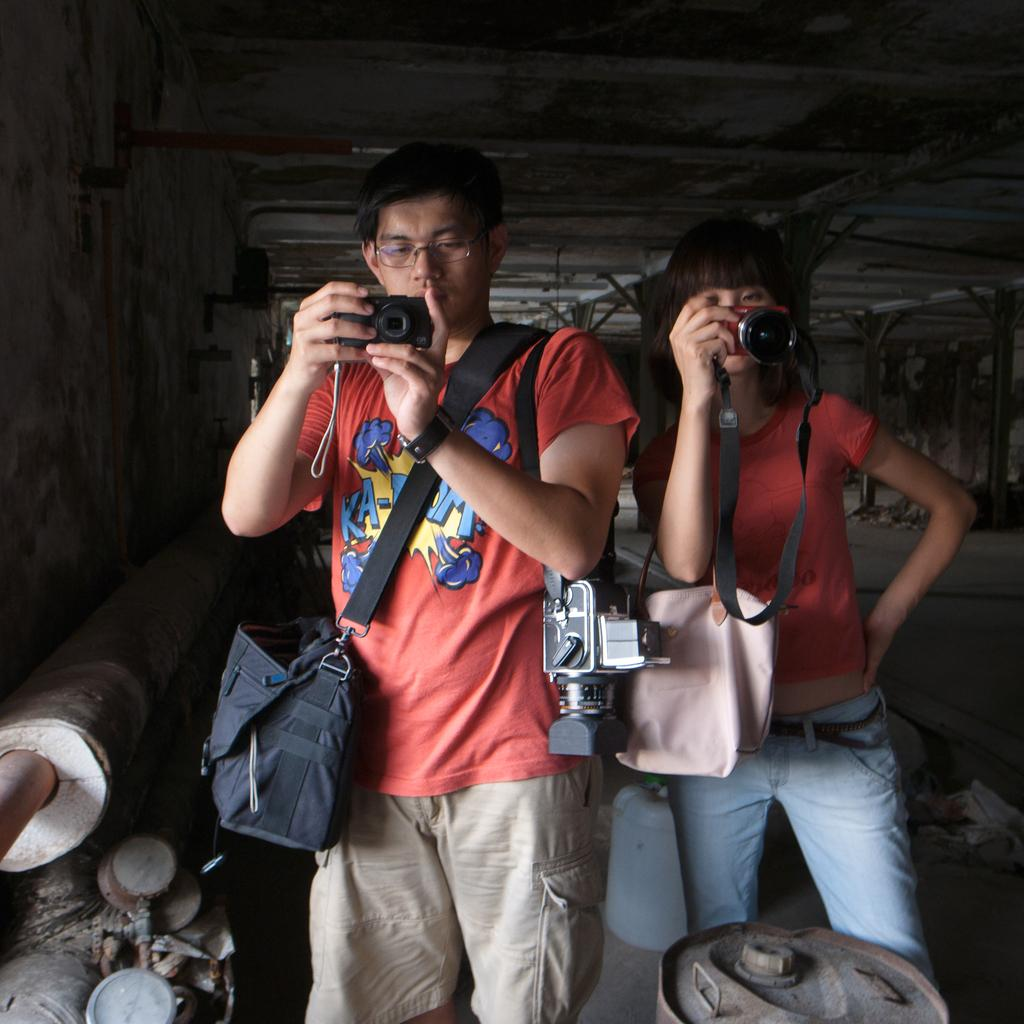What is the woman in the image wearing on her head? The woman in the image is wearing a hat. What is the man in the image wearing on his upper body? The man in the image is wearing a shirt. What are the woman and the man holding in their hands? Both the woman and the man are holding cameras in their hands. What items can be seen in the image that might be used for carrying belongings? There are bags visible in the image. What type of container is present in the image? There is a can in the image. How would you describe the lighting in the background of the image? The background of the image is dark. What type of face can be seen on the shirt of the man in the image? There is no face visible on the shirt of the man in the image. What type of waste is being disposed of in the image? There is no waste being disposed of in the image. 